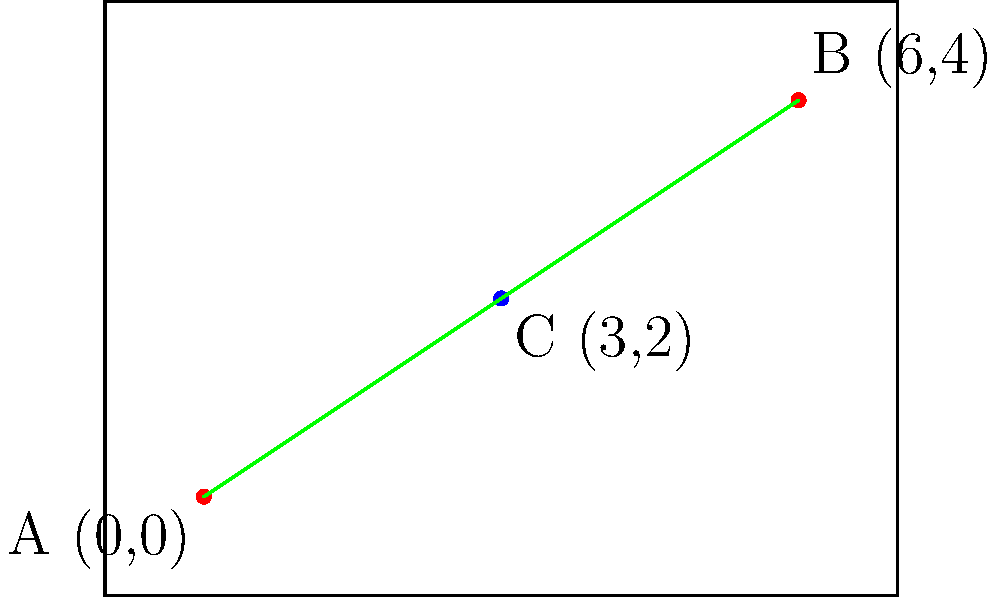On a rectangular stage diagram, two main spotlights are positioned at points A(0,0) and B(6,4). To create an optimal lighting effect for the illusionist's performance, you need to place a third light at point C(3,2). Calculate the total length of wiring needed to connect all three lights if the wiring must follow the edges of the triangle formed by these points. Round your answer to two decimal places. To solve this problem, we'll use the distance formula in coordinate geometry and follow these steps:

1) The distance formula between two points $(x_1, y_1)$ and $(x_2, y_2)$ is:
   $$d = \sqrt{(x_2-x_1)^2 + (y_2-y_1)^2}$$

2) Calculate the length of AC:
   $$AC = \sqrt{(3-0)^2 + (2-0)^2} = \sqrt{9 + 4} = \sqrt{13}$$

3) Calculate the length of BC:
   $$BC = \sqrt{(6-3)^2 + (4-2)^2} = \sqrt{9 + 4} = \sqrt{13}$$

4) Calculate the length of AB:
   $$AB = \sqrt{(6-0)^2 + (4-0)^2} = \sqrt{36 + 16} = \sqrt{52} = 2\sqrt{13}$$

5) The total length of wiring needed is the sum of AC, BC, and AB:
   $$Total = AC + BC + AB = \sqrt{13} + \sqrt{13} + 2\sqrt{13} = 4\sqrt{13}$$

6) Simplify and round to two decimal places:
   $$4\sqrt{13} \approx 14.42$$

Therefore, the total length of wiring needed is approximately 14.42 units.
Answer: 14.42 units 